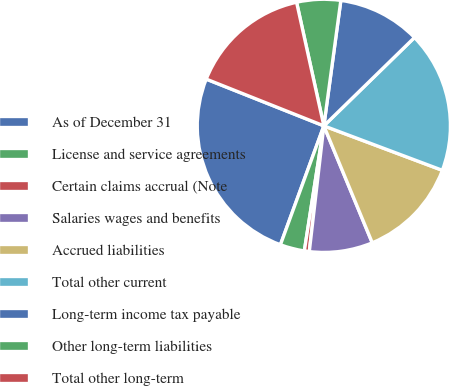Convert chart. <chart><loc_0><loc_0><loc_500><loc_500><pie_chart><fcel>As of December 31<fcel>License and service agreements<fcel>Certain claims accrual (Note<fcel>Salaries wages and benefits<fcel>Accrued liabilities<fcel>Total other current<fcel>Long-term income tax payable<fcel>Other long-term liabilities<fcel>Total other long-term<nl><fcel>25.45%<fcel>3.11%<fcel>0.63%<fcel>8.08%<fcel>13.04%<fcel>18.01%<fcel>10.56%<fcel>5.6%<fcel>15.52%<nl></chart> 